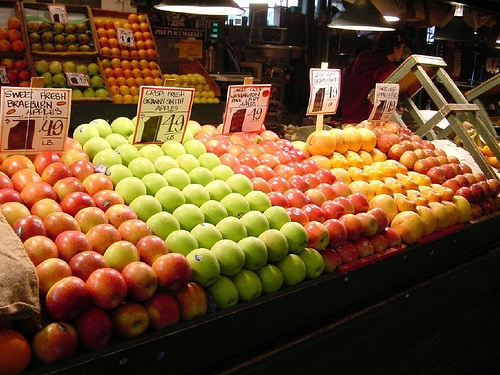Describe the objects in this image and their specific colors. I can see apple in black, maroon, orange, and brown tones, apple in black, khaki, olive, and darkgreen tones, apple in black, salmon, maroon, and red tones, orange in black, orange, khaki, and gold tones, and apple in black, tan, red, brown, and maroon tones in this image. 